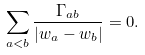Convert formula to latex. <formula><loc_0><loc_0><loc_500><loc_500>\sum _ { a < b } \frac { \Gamma _ { a b } } { | w _ { a } - w _ { b } | } = 0 .</formula> 